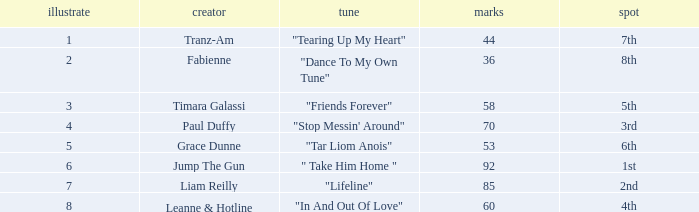What's the total number of points for grace dunne with a draw over 5? 0.0. 